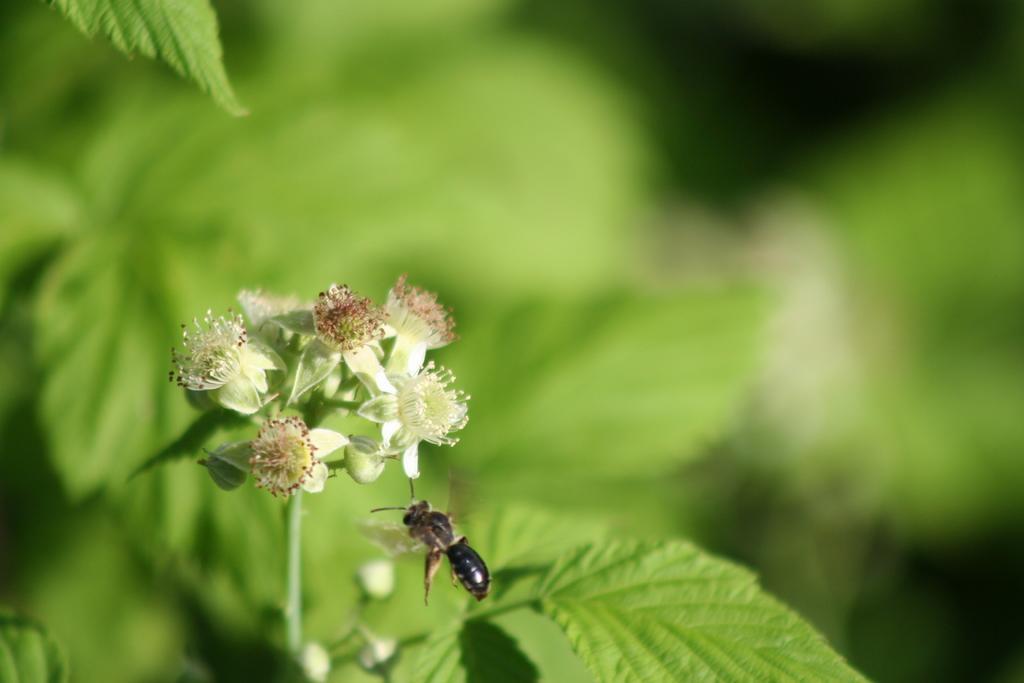How would you summarize this image in a sentence or two? In this picture I can see a plant with flowers and I can see a honey bee. 